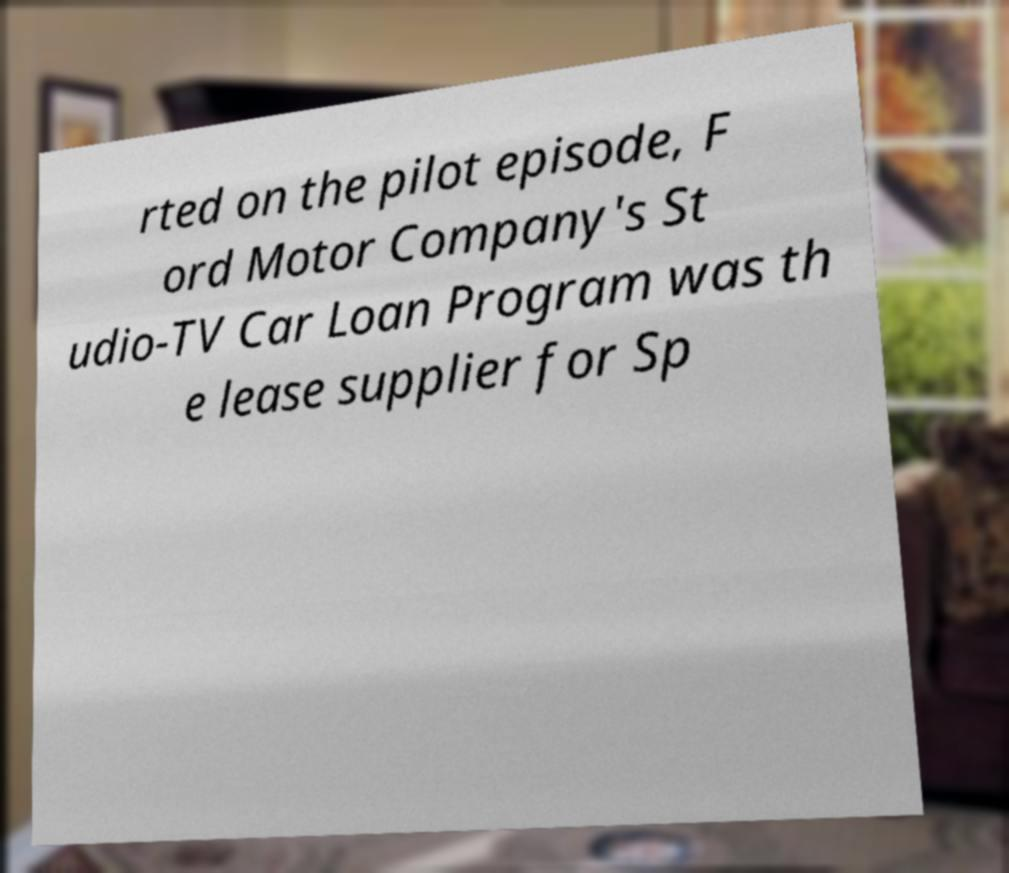Could you extract and type out the text from this image? rted on the pilot episode, F ord Motor Company's St udio-TV Car Loan Program was th e lease supplier for Sp 